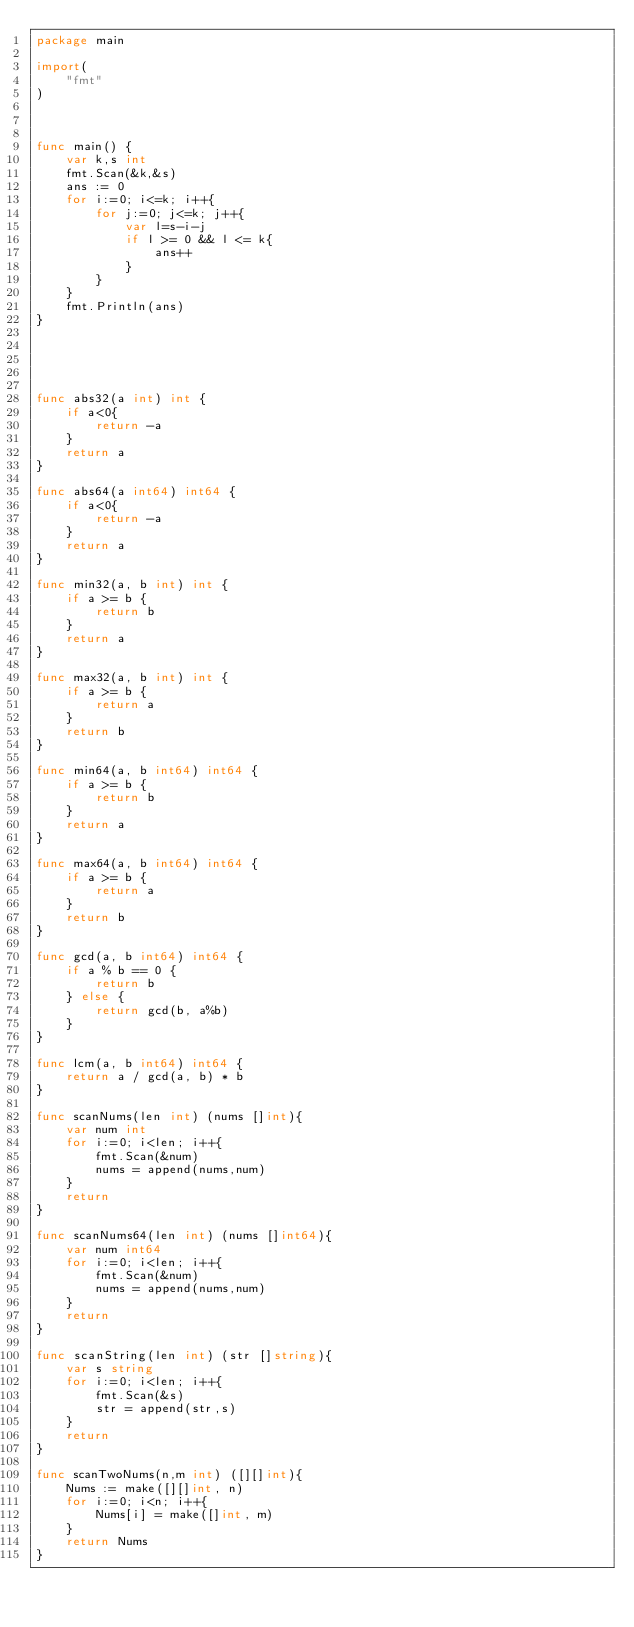<code> <loc_0><loc_0><loc_500><loc_500><_Go_>package main

import(
    "fmt"
)



func main() {
    var k,s int
    fmt.Scan(&k,&s)
    ans := 0
    for i:=0; i<=k; i++{
        for j:=0; j<=k; j++{
            var l=s-i-j
            if l >= 0 && l <= k{
                ans++
            }
        }
    }
    fmt.Println(ans)
}





func abs32(a int) int {
    if a<0{
        return -a
    }
    return a
}

func abs64(a int64) int64 {
    if a<0{
        return -a
    }
    return a
}

func min32(a, b int) int {
    if a >= b {
        return b
    }
    return a
}

func max32(a, b int) int {
    if a >= b {
        return a
    }
    return b
}

func min64(a, b int64) int64 {
    if a >= b {
        return b
    }
    return a
}

func max64(a, b int64) int64 {
    if a >= b {
        return a
    }
    return b
}

func gcd(a, b int64) int64 {
    if a % b == 0 {
        return b
    } else {
        return gcd(b, a%b)
    }
}

func lcm(a, b int64) int64 {
    return a / gcd(a, b) * b
}

func scanNums(len int) (nums []int){
    var num int
    for i:=0; i<len; i++{
        fmt.Scan(&num)
        nums = append(nums,num)
    }
    return
}

func scanNums64(len int) (nums []int64){
    var num int64
    for i:=0; i<len; i++{
        fmt.Scan(&num)
        nums = append(nums,num)
    }
    return
}

func scanString(len int) (str []string){
    var s string
    for i:=0; i<len; i++{
        fmt.Scan(&s)
        str = append(str,s)
    }
    return
}

func scanTwoNums(n,m int) ([][]int){
    Nums := make([][]int, n)
    for i:=0; i<n; i++{
        Nums[i] = make([]int, m)
    }
    return Nums
}
</code> 